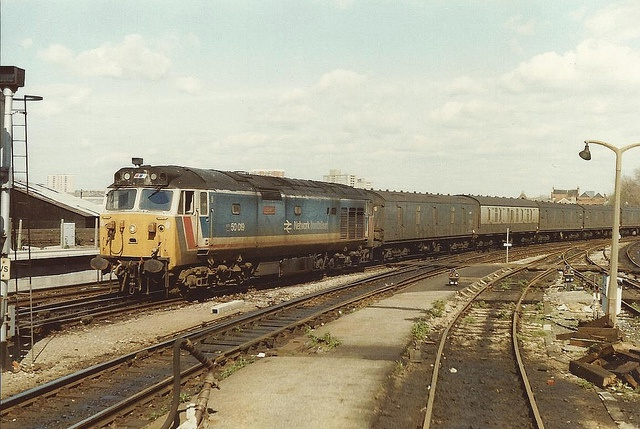Describe the objects in this image and their specific colors. I can see a train in lightgray, gray, and black tones in this image. 